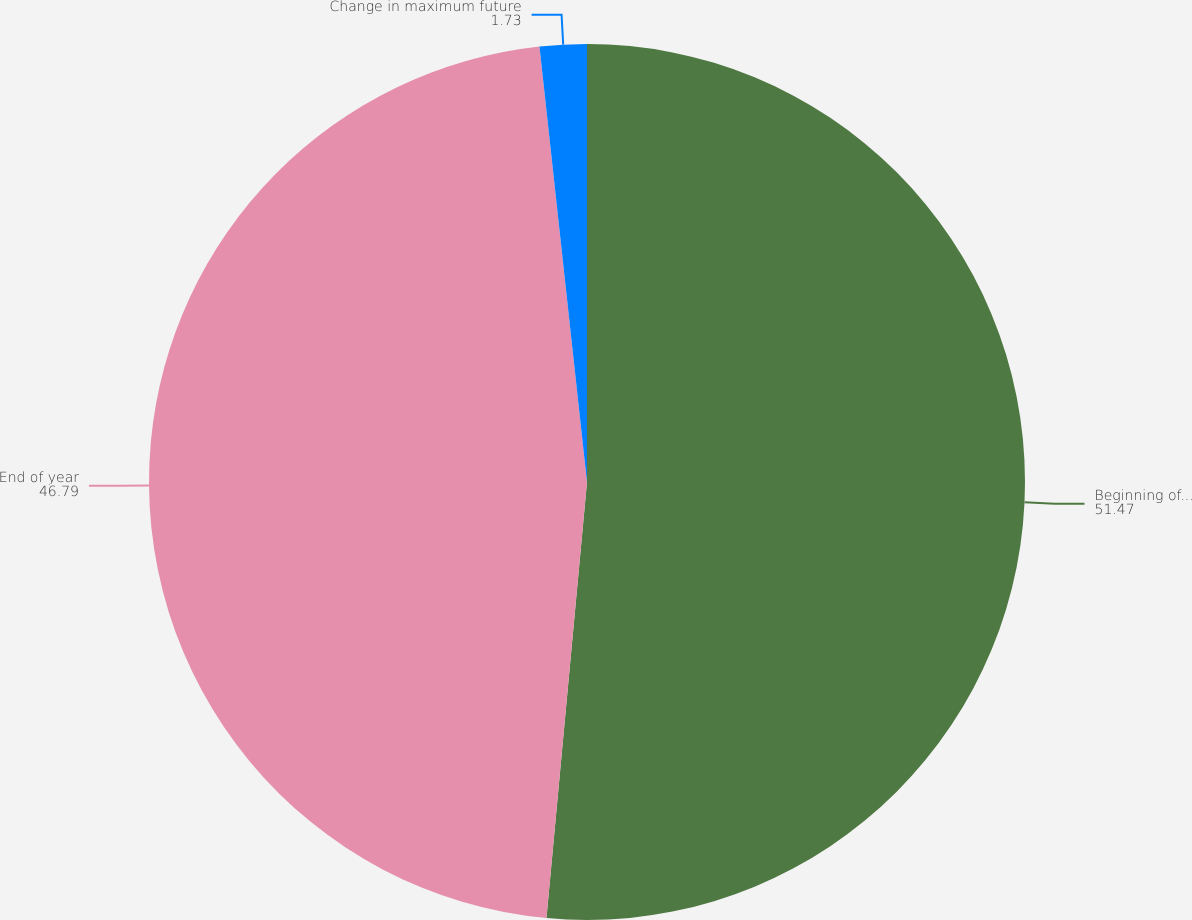Convert chart. <chart><loc_0><loc_0><loc_500><loc_500><pie_chart><fcel>Beginning of year<fcel>End of year<fcel>Change in maximum future<nl><fcel>51.47%<fcel>46.79%<fcel>1.73%<nl></chart> 